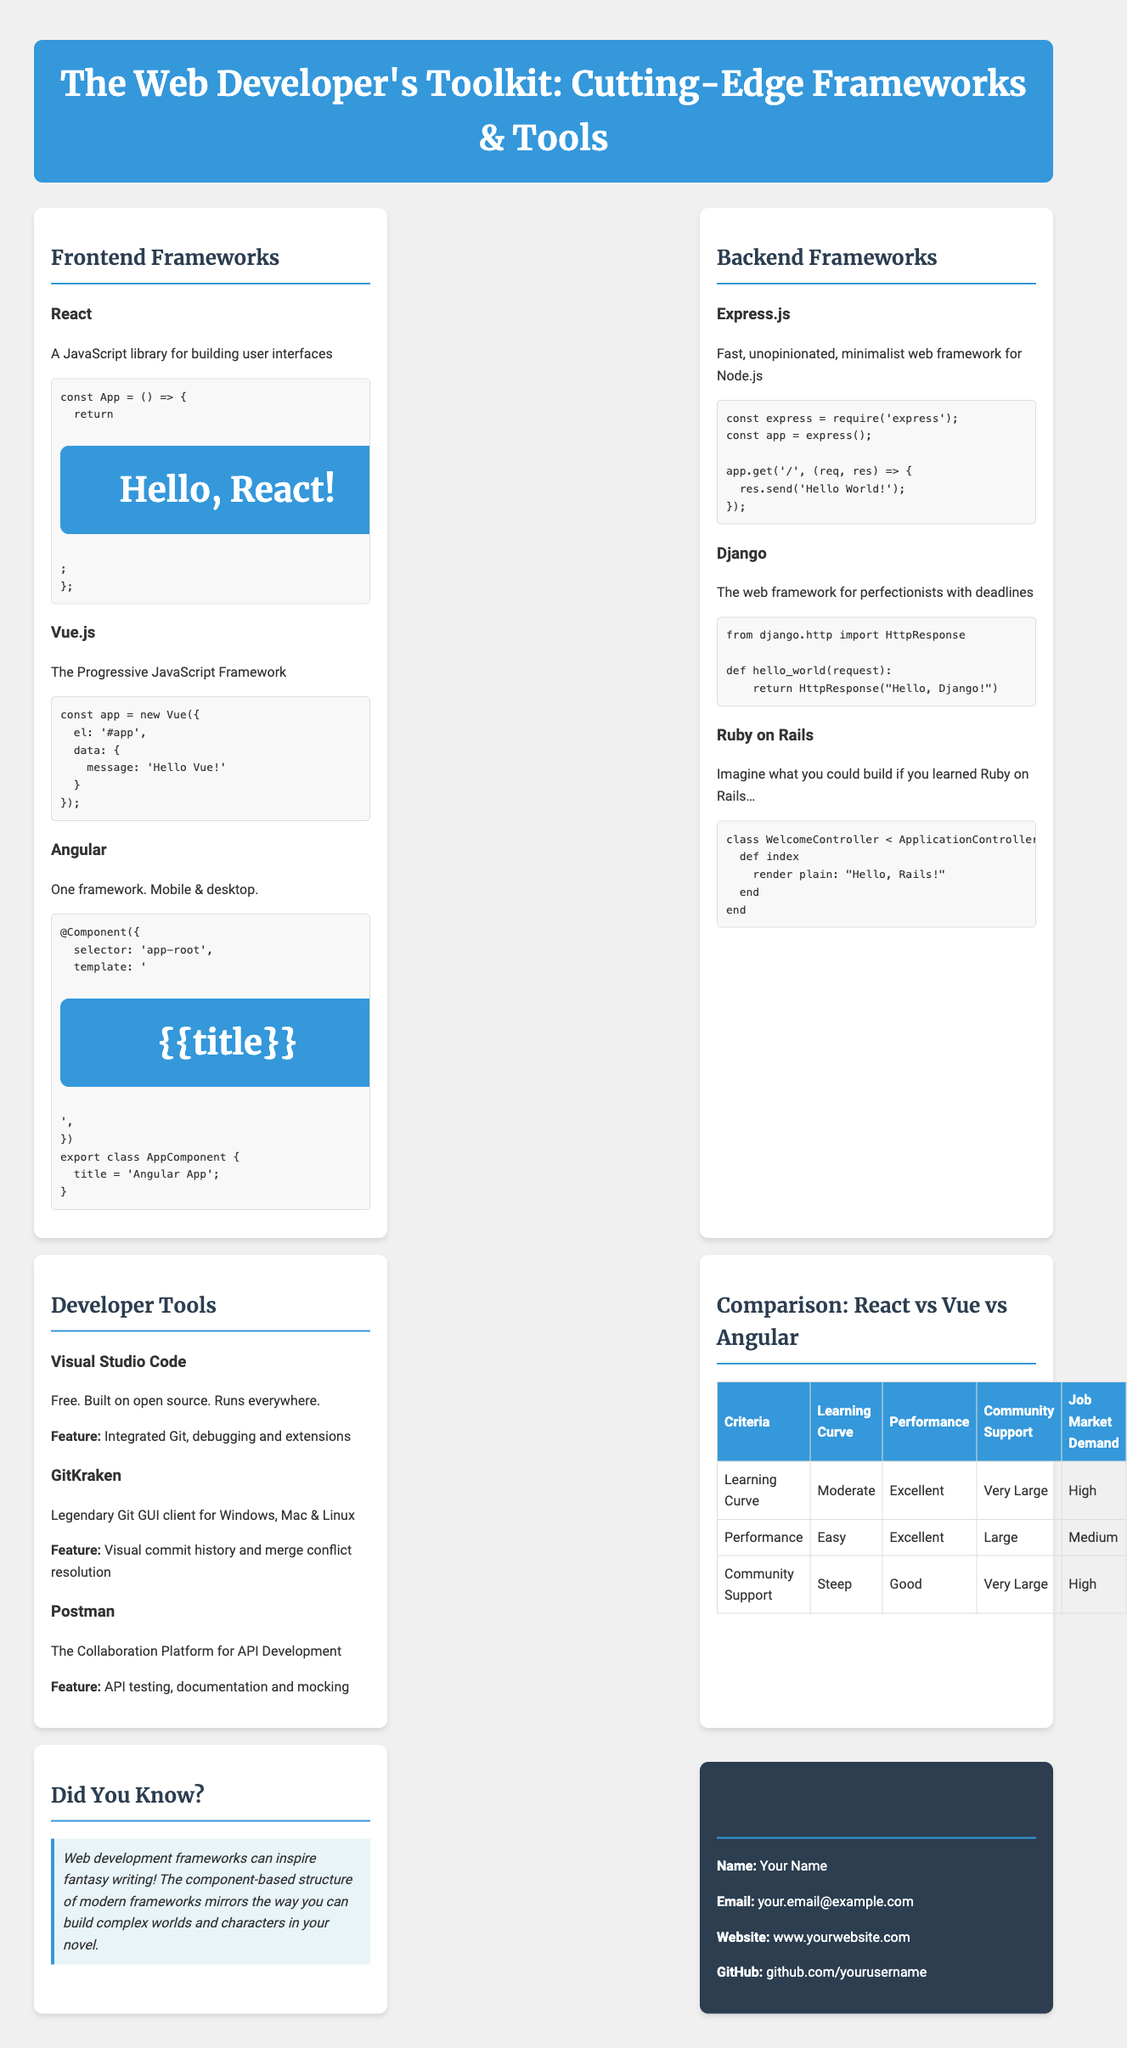What is the title of the brochure? The title of the brochure is presented at the top of the document and specifies the theme and topic discussed.
Answer: The Web Developer's Toolkit: Cutting-Edge Frameworks & Tools How many frontend frameworks are listed? The brochure includes a section on frontend frameworks, which lists specific frameworks under that category.
Answer: Three What is the code snippet for Vue.js? Each framework includes a code snippet in a predefined format for demonstration purposes.
Answer: const app = new Vue({ el: '#app', data: { message: 'Hello Vue!' } }); What feature does Visual Studio Code offer? The document includes a list of key features associated with various developer tools; Visual Studio Code's feature is highlighted specifically.
Answer: Integrated Git, debugging and extensions Which backend framework is described as "The web framework for perfectionists with deadlines"? Framework descriptions provide a brief insight into each framework's focus or intended purpose.
Answer: Django Which framework has a steep learning curve? The comparison section offers insights into the learning curves of different frameworks, allowing for direct comparison.
Answer: Angular What is the community support rating for Vue.js? Information about community support levels for each framework can be found in the comparison section.
Answer: Large What unique fact is mentioned in the "Did You Know?" section? This section provides an interesting insight linking web development frameworks to fantasy writing.
Answer: Web development frameworks can inspire fantasy writing! 